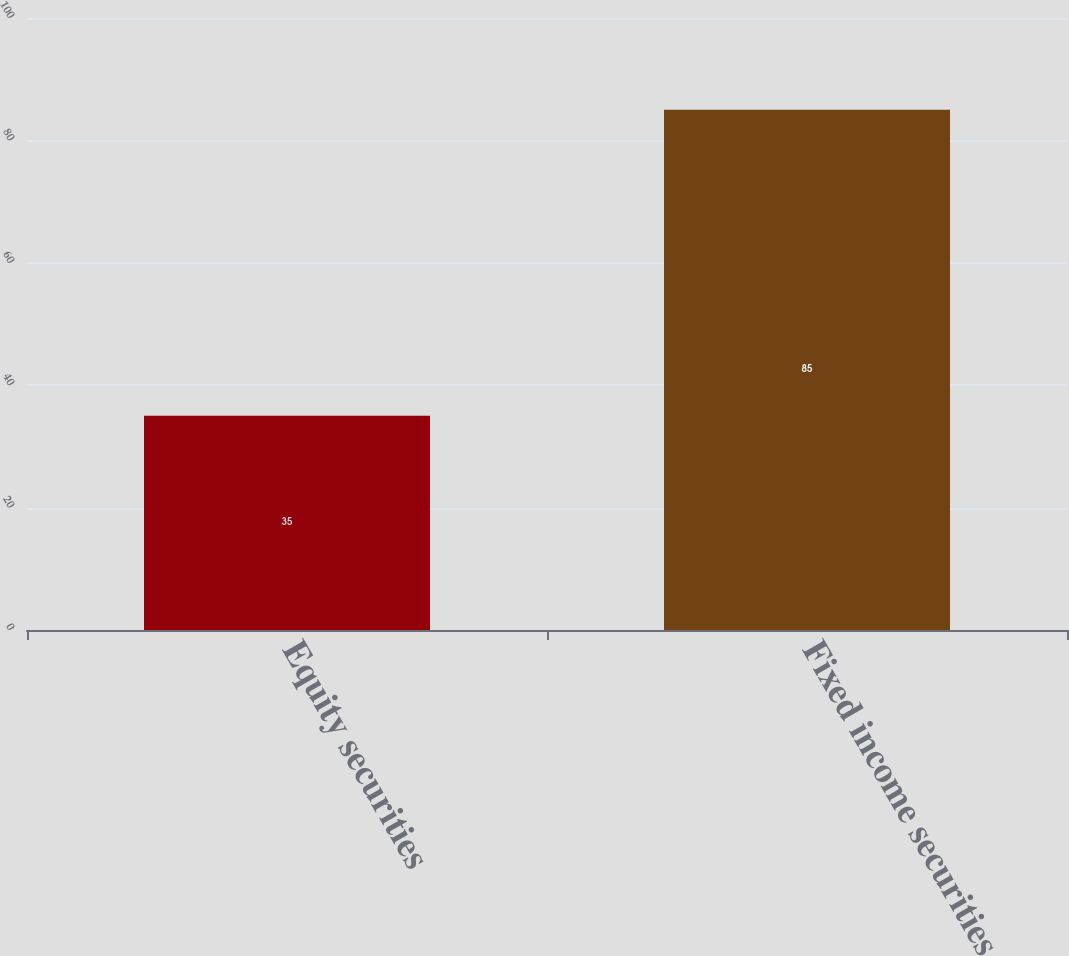<chart> <loc_0><loc_0><loc_500><loc_500><bar_chart><fcel>Equity securities<fcel>Fixed income securities<nl><fcel>35<fcel>85<nl></chart> 